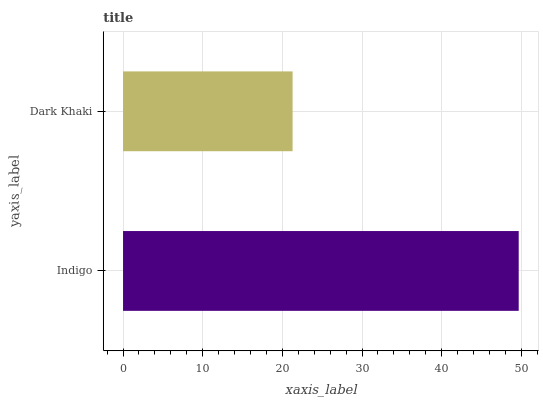Is Dark Khaki the minimum?
Answer yes or no. Yes. Is Indigo the maximum?
Answer yes or no. Yes. Is Dark Khaki the maximum?
Answer yes or no. No. Is Indigo greater than Dark Khaki?
Answer yes or no. Yes. Is Dark Khaki less than Indigo?
Answer yes or no. Yes. Is Dark Khaki greater than Indigo?
Answer yes or no. No. Is Indigo less than Dark Khaki?
Answer yes or no. No. Is Indigo the high median?
Answer yes or no. Yes. Is Dark Khaki the low median?
Answer yes or no. Yes. Is Dark Khaki the high median?
Answer yes or no. No. Is Indigo the low median?
Answer yes or no. No. 